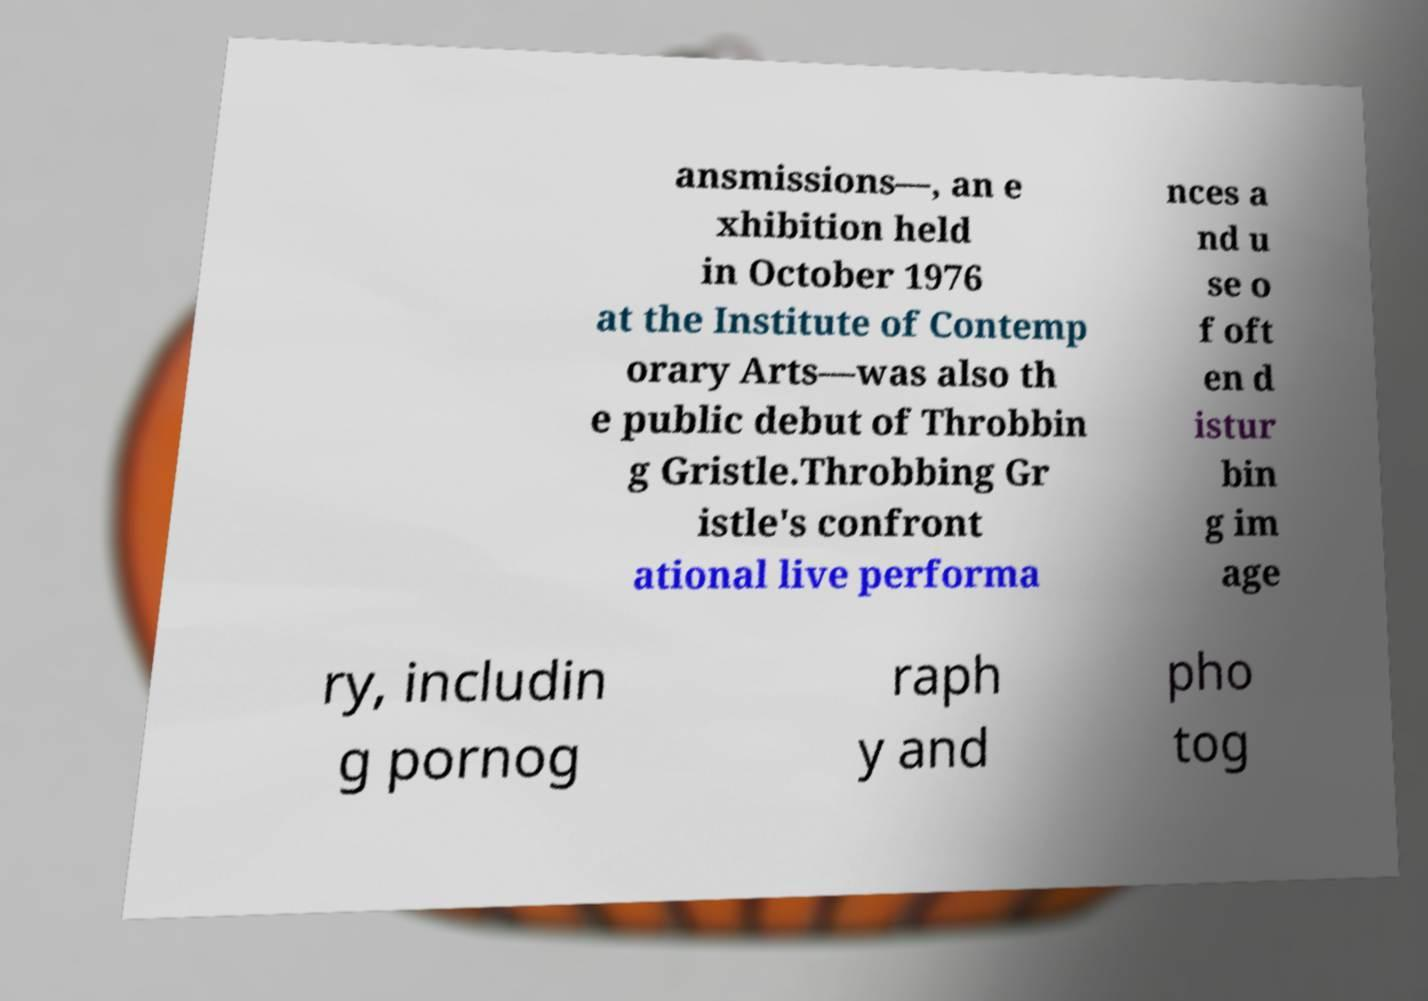There's text embedded in this image that I need extracted. Can you transcribe it verbatim? ansmissions—, an e xhibition held in October 1976 at the Institute of Contemp orary Arts—was also th e public debut of Throbbin g Gristle.Throbbing Gr istle's confront ational live performa nces a nd u se o f oft en d istur bin g im age ry, includin g pornog raph y and pho tog 